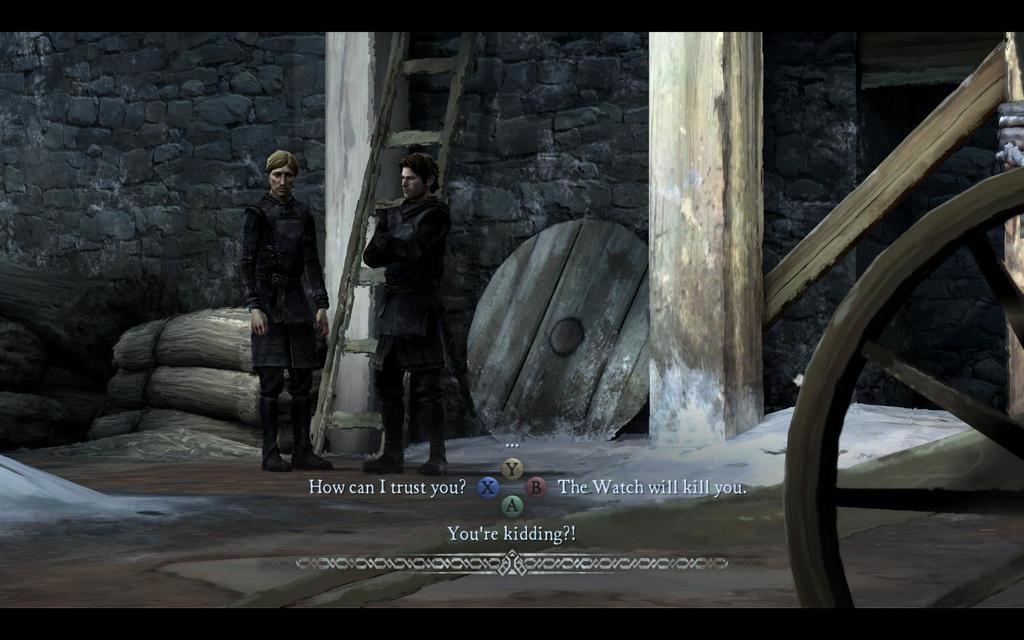Could you give a brief overview of what you see in this image? This is an animated image, there are two persons standing, there is a ladder truncated towards the top of the image, there is the wall truncated towards the top of the image, there is the wall truncated towards the left of the image, there are pillars truncated towards the top of the image, there are objects on the ground, there is a wheel truncated towards the right of the image, there is an object truncated towards the left of the image, there is an object truncated towards the right of the image. 